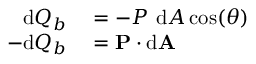<formula> <loc_0><loc_0><loc_500><loc_500>\begin{array} { r l } { d Q _ { b } } & = - P \ d A \cos ( \theta ) } \\ { - d Q _ { b } } & = P \cdot d A } \end{array}</formula> 